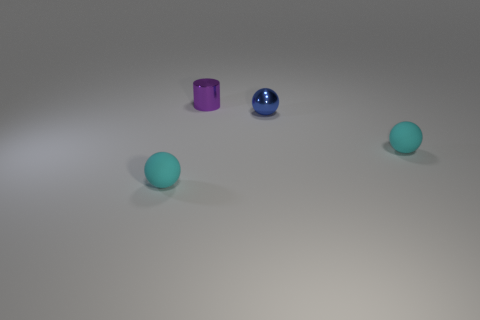Subtract all cyan balls. How many balls are left? 1 Subtract 1 spheres. How many spheres are left? 2 Add 3 tiny shiny cylinders. How many objects exist? 7 Subtract all cylinders. How many objects are left? 3 Add 1 rubber objects. How many rubber objects exist? 3 Subtract 0 purple balls. How many objects are left? 4 Subtract all cyan metallic blocks. Subtract all blue metallic things. How many objects are left? 3 Add 4 purple metal things. How many purple metal things are left? 5 